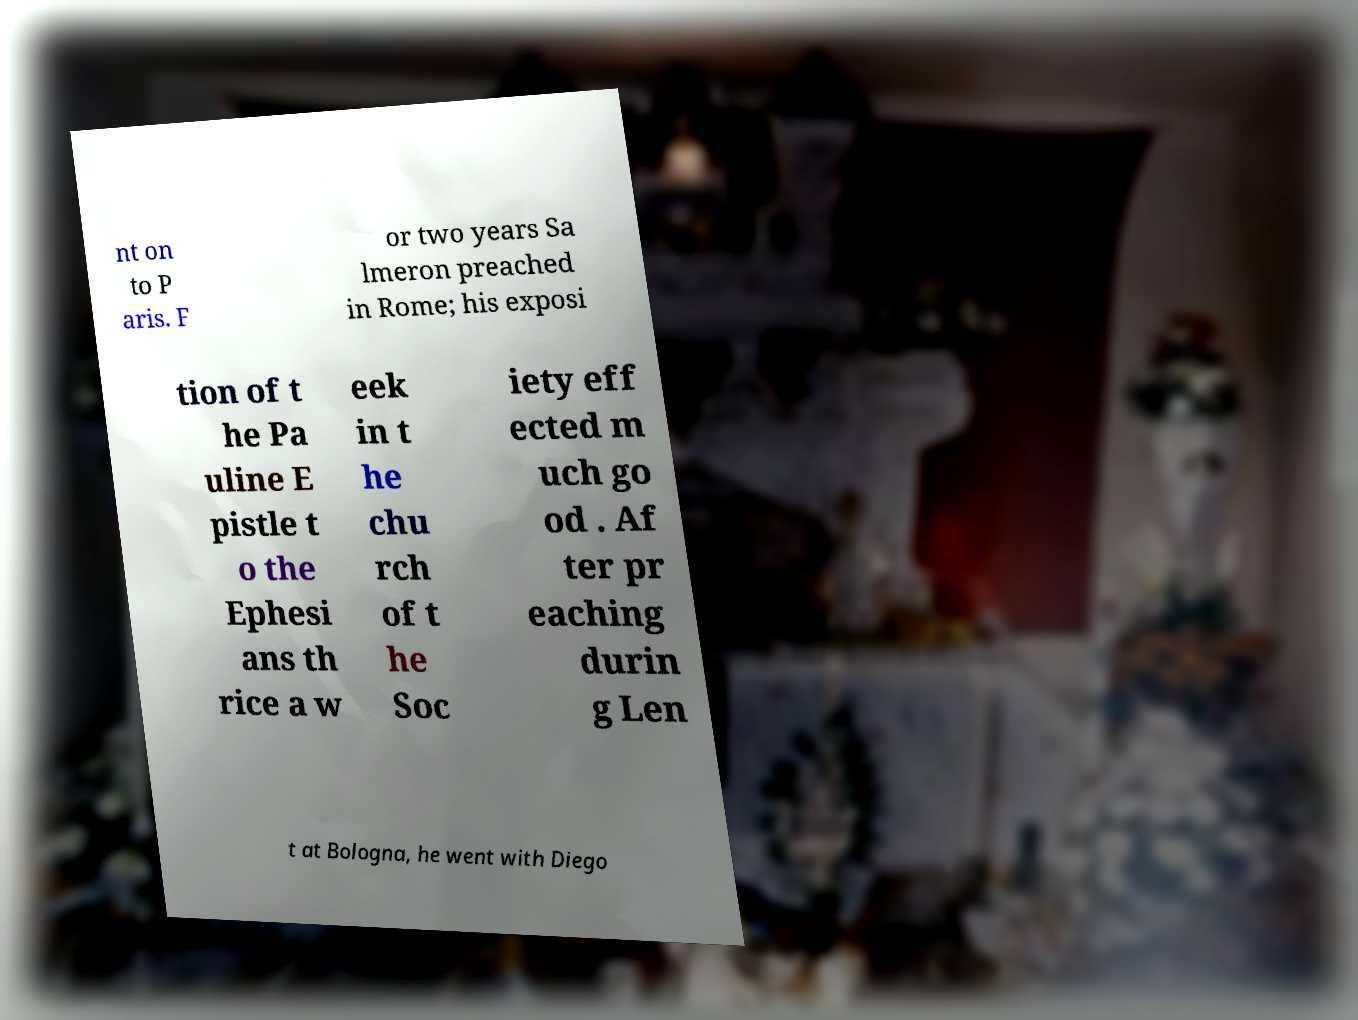Can you accurately transcribe the text from the provided image for me? nt on to P aris. F or two years Sa lmeron preached in Rome; his exposi tion of t he Pa uline E pistle t o the Ephesi ans th rice a w eek in t he chu rch of t he Soc iety eff ected m uch go od . Af ter pr eaching durin g Len t at Bologna, he went with Diego 